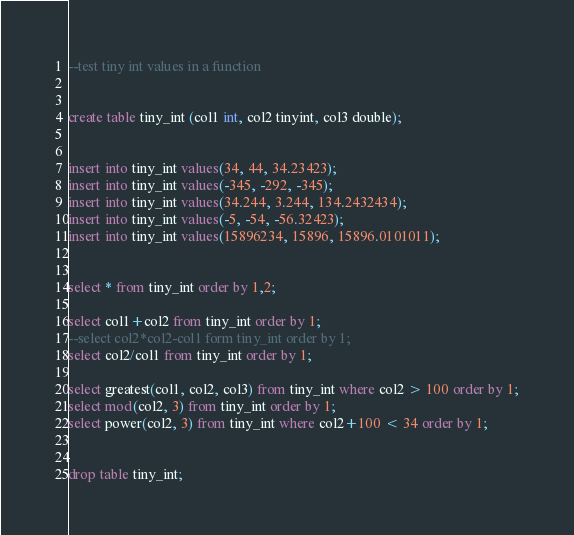<code> <loc_0><loc_0><loc_500><loc_500><_SQL_>--test tiny int values in a function


create table tiny_int (col1 int, col2 tinyint, col3 double);


insert into tiny_int values(34, 44, 34.23423);
insert into tiny_int values(-345, -292, -345);
insert into tiny_int values(34.244, 3.244, 134.2432434);
insert into tiny_int values(-5, -54, -56.32423);
insert into tiny_int values(15896234, 15896, 15896.0101011);


select * from tiny_int order by 1,2;

select col1+col2 from tiny_int order by 1;
--select col2*col2-col1 form tiny_int order by 1;
select col2/col1 from tiny_int order by 1;

select greatest(col1, col2, col3) from tiny_int where col2 > 100 order by 1;
select mod(col2, 3) from tiny_int order by 1;
select power(col2, 3) from tiny_int where col2+100 < 34 order by 1;


drop table tiny_int;



</code> 